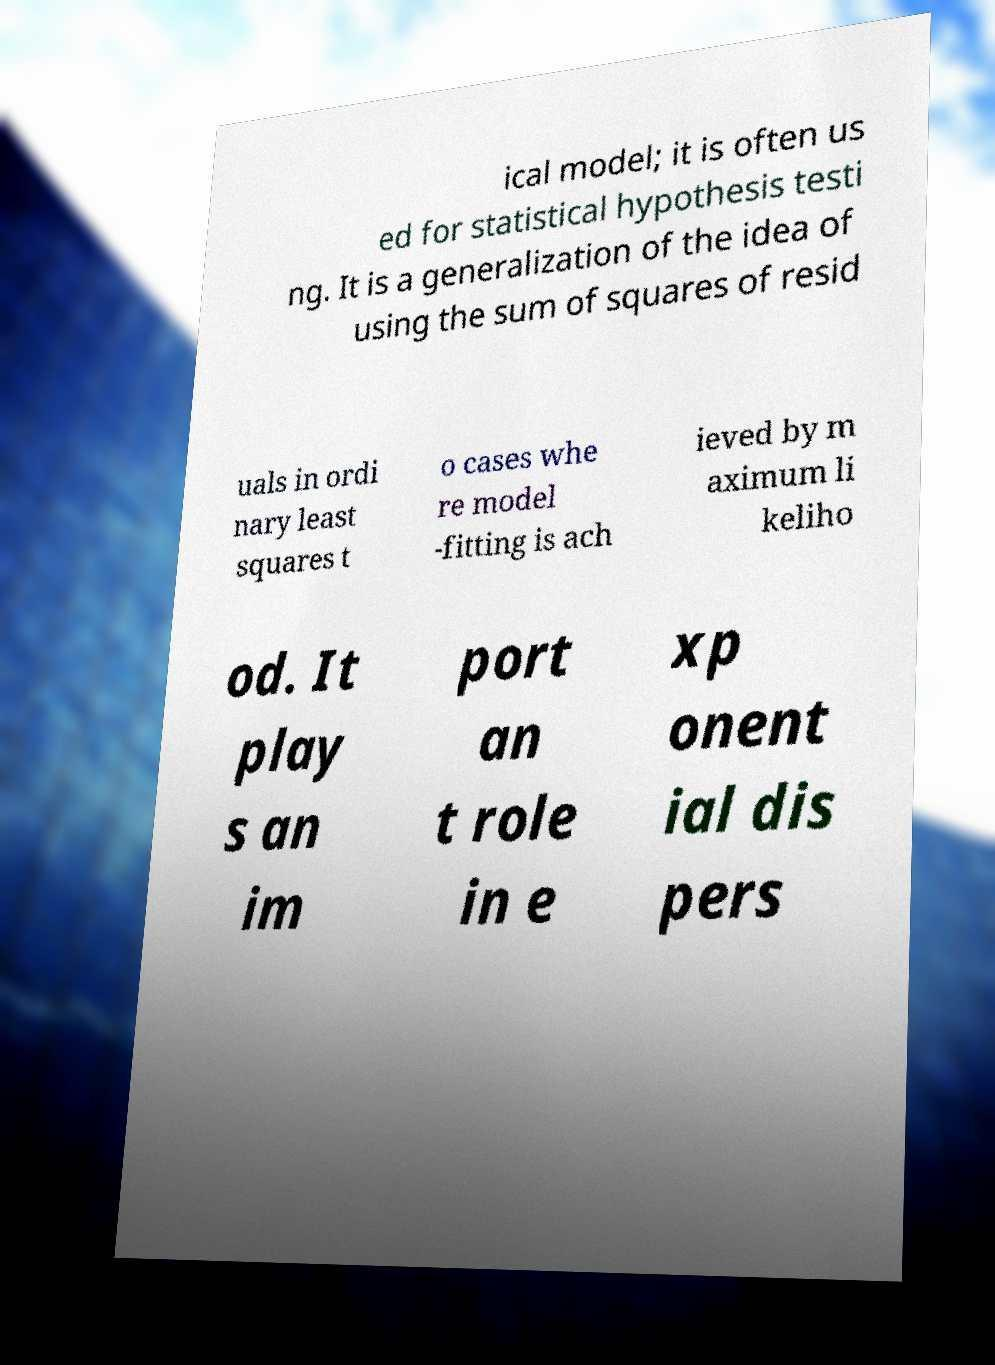What messages or text are displayed in this image? I need them in a readable, typed format. ical model; it is often us ed for statistical hypothesis testi ng. It is a generalization of the idea of using the sum of squares of resid uals in ordi nary least squares t o cases whe re model -fitting is ach ieved by m aximum li keliho od. It play s an im port an t role in e xp onent ial dis pers 